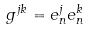<formula> <loc_0><loc_0><loc_500><loc_500>g ^ { j k } = e ^ { j } _ { n } e ^ { k } _ { n }</formula> 